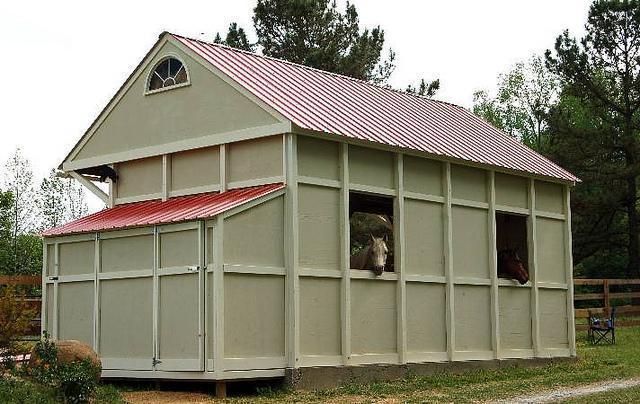How many horses are looking at the camera?
Give a very brief answer. 1. How many windows are shown on the front of the house?
Give a very brief answer. 2. 